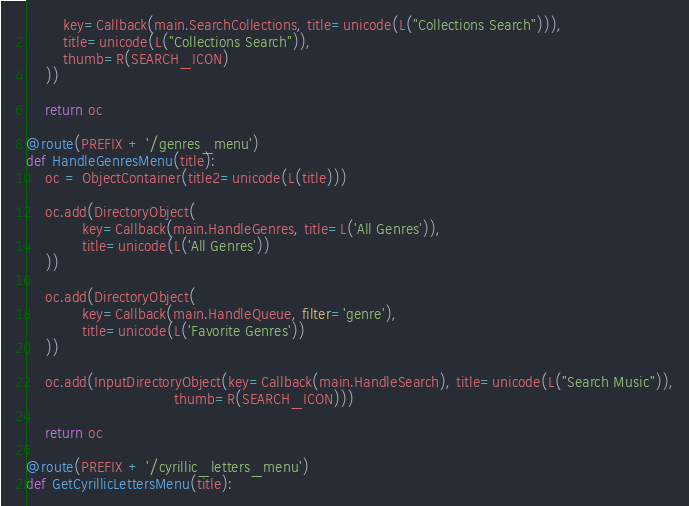<code> <loc_0><loc_0><loc_500><loc_500><_Python_>        key=Callback(main.SearchCollections, title=unicode(L("Collections Search"))),
        title=unicode(L("Collections Search")),
        thumb=R(SEARCH_ICON)
    ))

    return oc

@route(PREFIX + '/genres_menu')
def HandleGenresMenu(title):
    oc = ObjectContainer(title2=unicode(L(title)))

    oc.add(DirectoryObject(
            key=Callback(main.HandleGenres, title=L('All Genres')),
            title=unicode(L('All Genres'))
    ))

    oc.add(DirectoryObject(
            key=Callback(main.HandleQueue, filter='genre'),
            title=unicode(L('Favorite Genres'))
    ))

    oc.add(InputDirectoryObject(key=Callback(main.HandleSearch), title=unicode(L("Search Music")),
                                thumb=R(SEARCH_ICON)))

    return oc

@route(PREFIX + '/cyrillic_letters_menu')
def GetCyrillicLettersMenu(title):</code> 